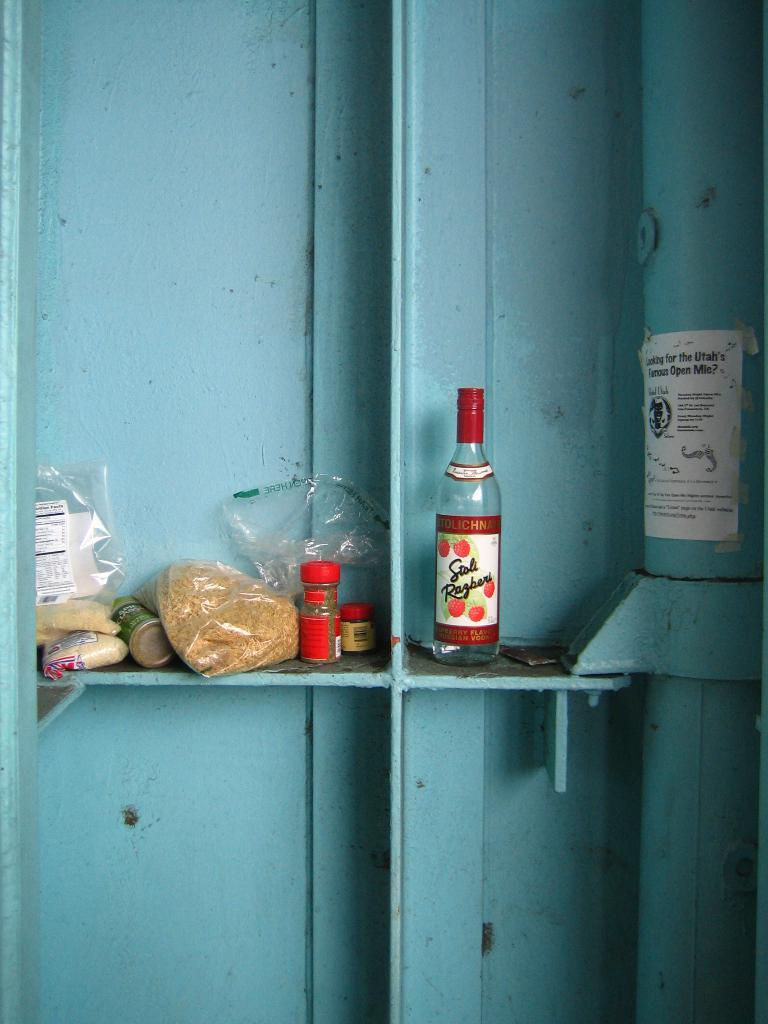What object is located on the right side of the image? There is a bottle on the right side of the image. What can be seen on the left side of the image? There is a plastic cover with food on the left side of the image, and a plastic jar with something in it. Is there an island visible in the image? No, there is no island present in the image. Can you see a fight happening in the image? No, there is no fight depicted in the image. 